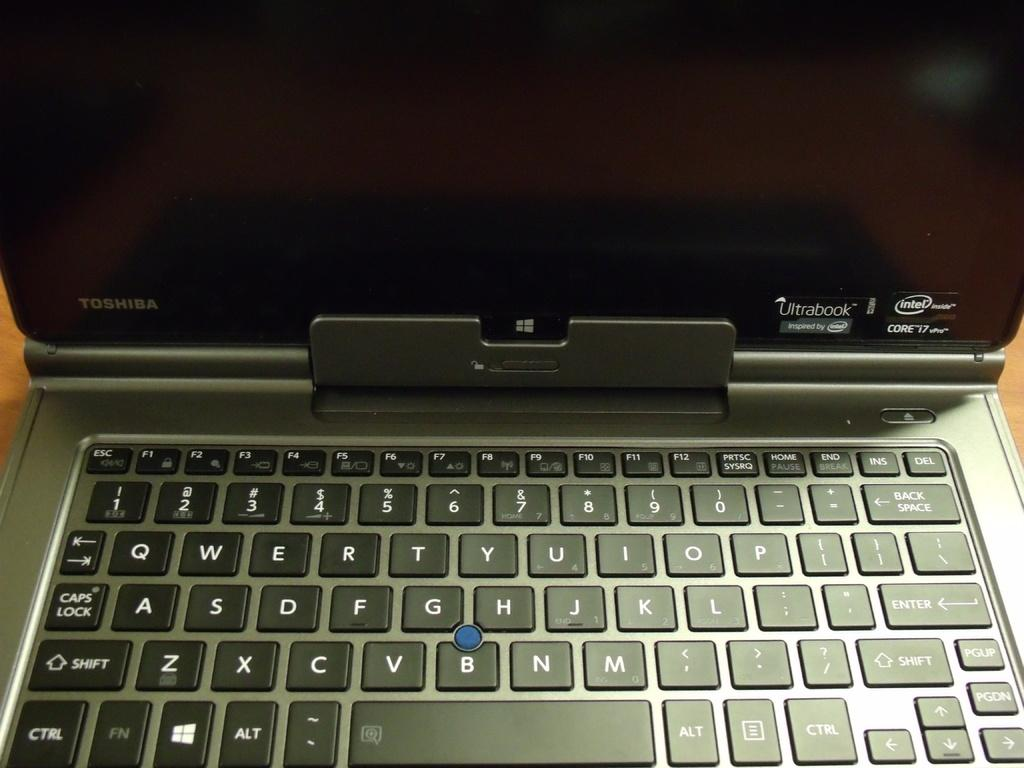<image>
Provide a brief description of the given image. An open Toshiba Ultrabook laptop with an old style pointing stick instead of a touchpad. 